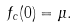<formula> <loc_0><loc_0><loc_500><loc_500>f _ { c } ( 0 ) = \mu .</formula> 